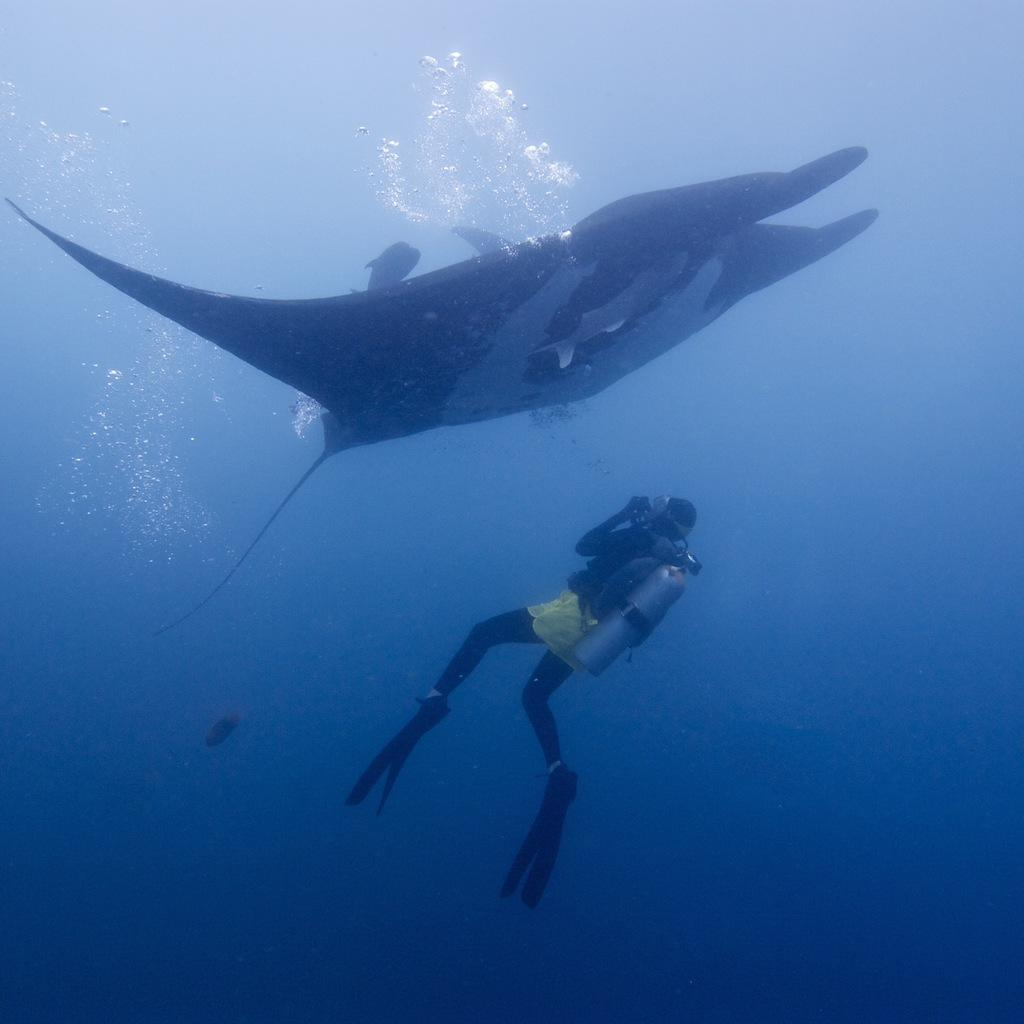What type of animals can be seen in the image? There are water animals in the image. Can you describe the person in the water? The person is wearing a swimsuit and has an oxygen cylinder on their back. What type of board is the person riding in the image? There is no board present in the image; the person is swimming with an oxygen cylinder. How is the string used in the image? There is no string present in the image. 